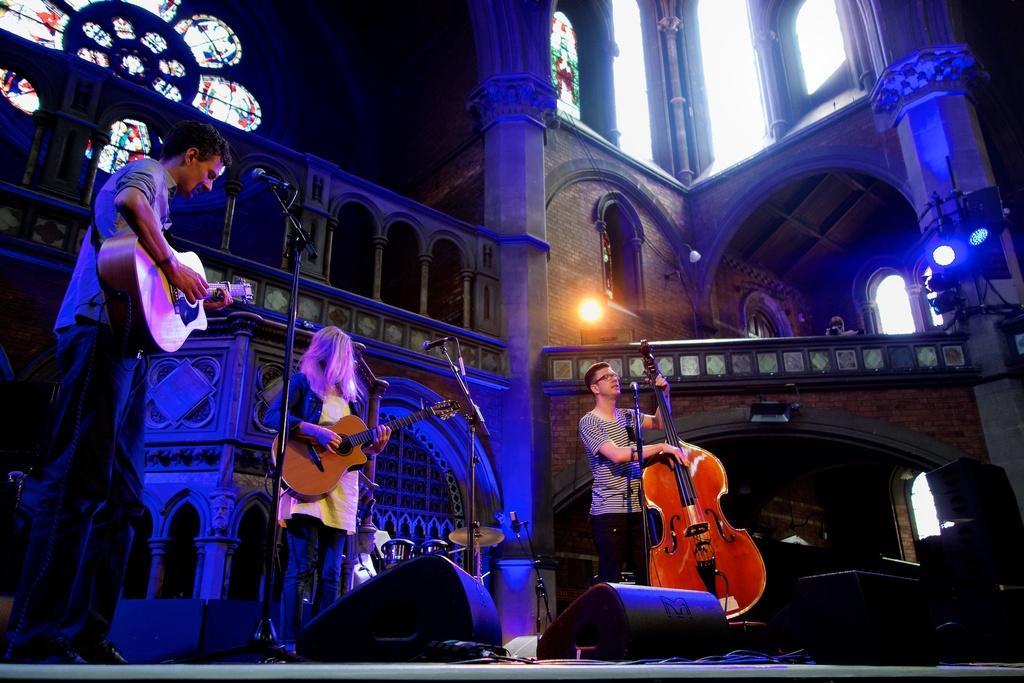Can you describe this image briefly? This is a picture taken on a stage, there are three persons standing on a stage and holding a music instrument in front of these people there are microphones with stands and on the stage there are some music systems. Behind the people there is a wall glass window, lights and on top of the floor there is a person holding camera. 